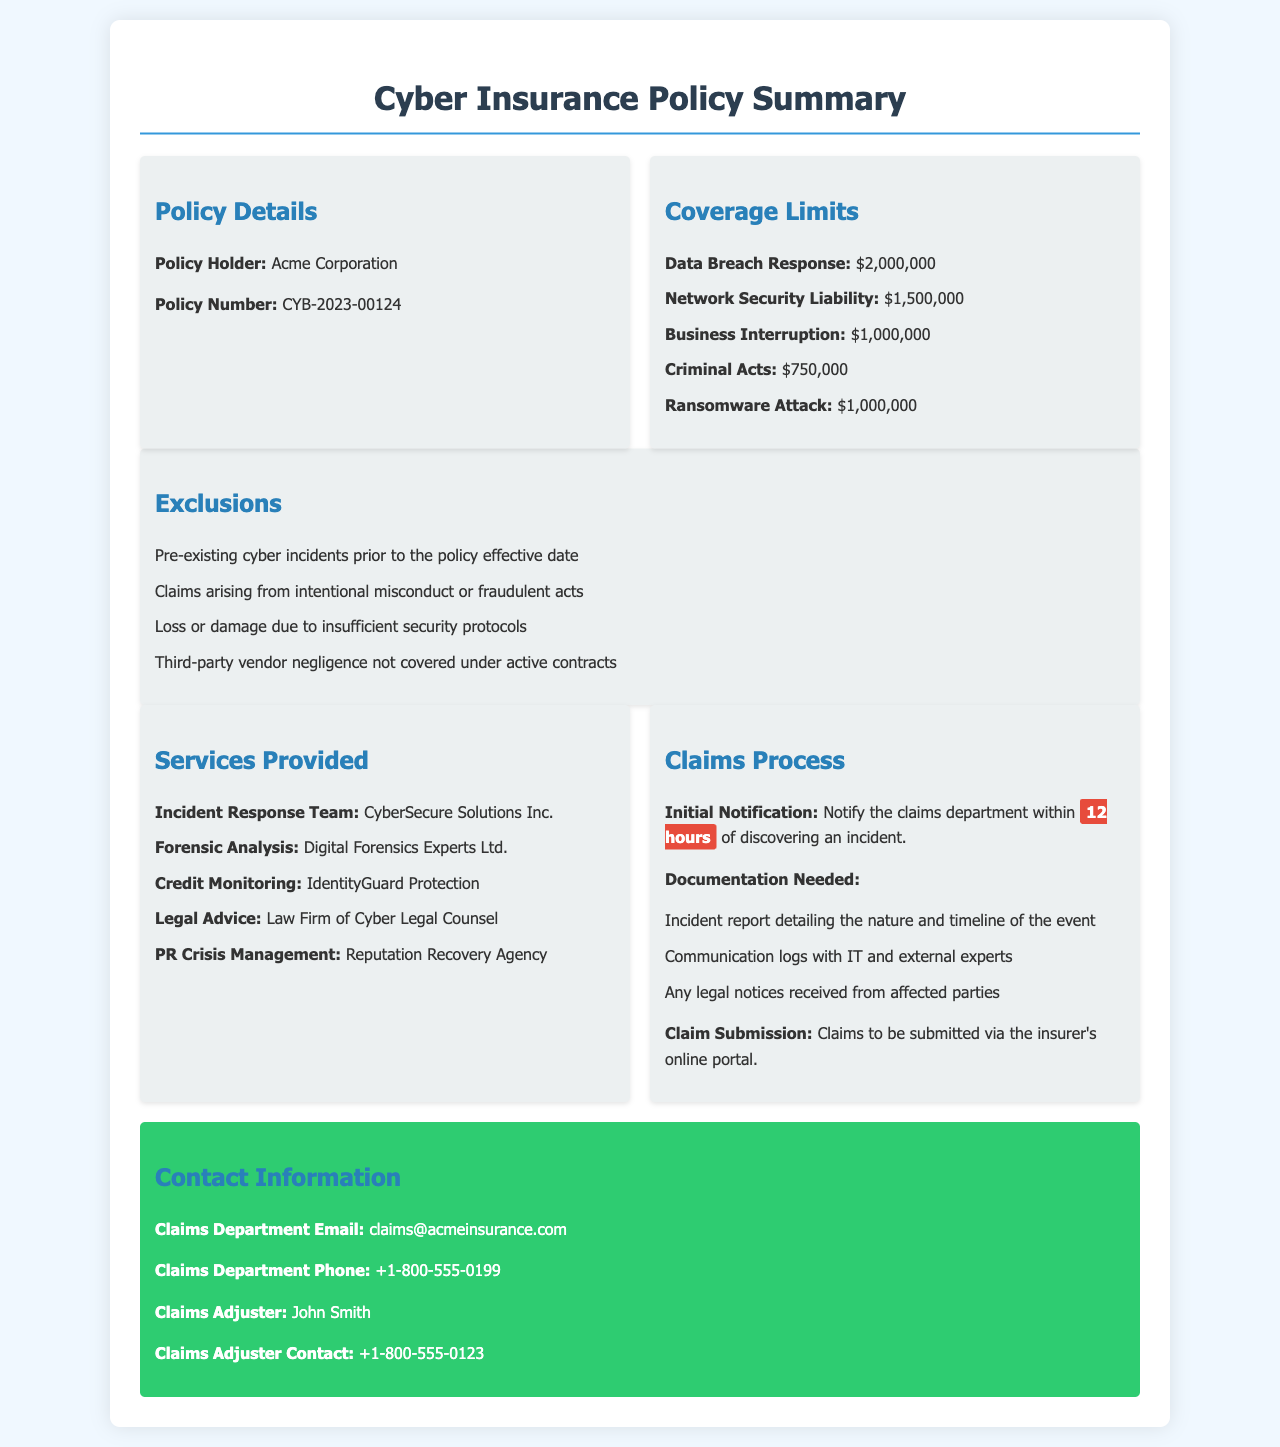What is the policy number? The policy number is stated in the Policy Details section of the document, which is CYB-2023-00124.
Answer: CYB-2023-00124 What is the coverage limit for Data Breach Response? The coverage limit for Data Breach Response is specified in the Coverage Limits section of the document as $2,000,000.
Answer: $2,000,000 Which company provides incident response services? The document lists CyberSecure Solutions Inc. as the provider of incident response services in the Services Provided section.
Answer: CyberSecure Solutions Inc What is excluded from the coverage? The document details exclusions in the Exclusions section; one of the exclusions is claims arising from intentional misconduct or fraudulent acts.
Answer: Claims arising from intentional misconduct or fraudulent acts What is the time frame for initial notification of an incident? The document states that initial notification must occur within 12 hours of discovering an incident, which can be found in the Claims Process section.
Answer: 12 hours Who is the claims adjuster? The claims adjuster’s name is found in the Contact Information section of the document, which is John Smith.
Answer: John Smith What is the coverage limit for Ransomware Attack? The coverage limit for Ransomware Attack is noted in the Coverage Limits section as $1,000,000.
Answer: $1,000,000 What documentation is needed for a claim submission? The document lists several required documents for claim submission; one of them is an incident report detailing the nature and timeline of the event.
Answer: Incident report detailing the nature and timeline of the event 